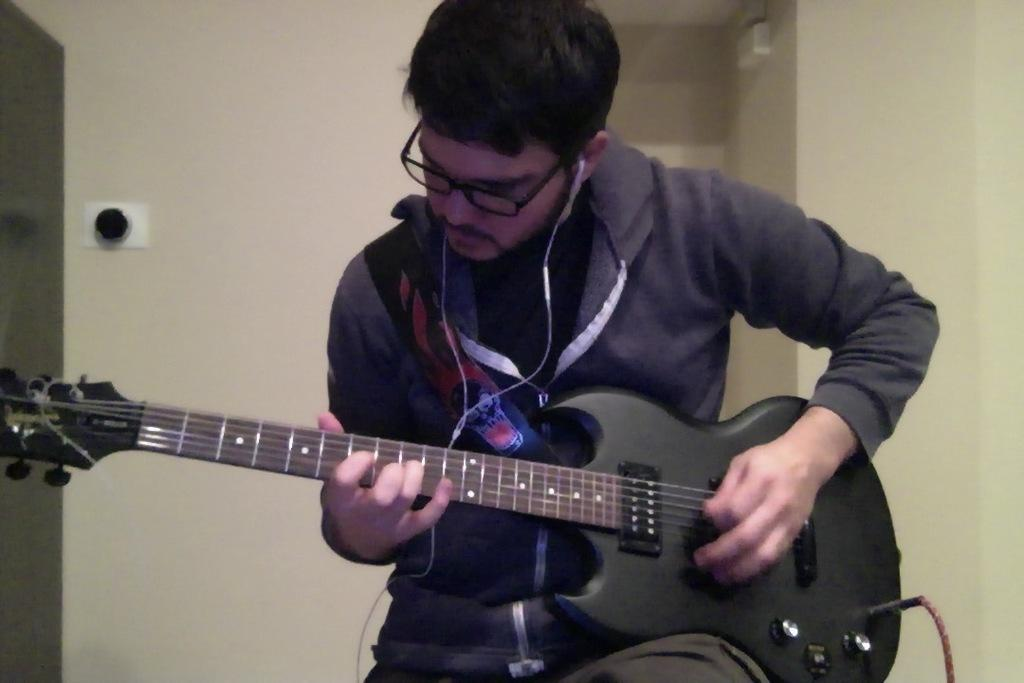What is happening in the image? There is a person in the image, and they are playing the guitar. Can you describe the person's activity in more detail? The person is playing the guitar, which means they are using their hands to strum or pluck the strings of the instrument, likely producing musical notes or chords. What type of prison can be seen in the background of the image? There is no prison present in the image; it only features a person playing the guitar. What type of celery is being used as a prop in the image? There is no celery present in the image; it only features a person playing the guitar. 